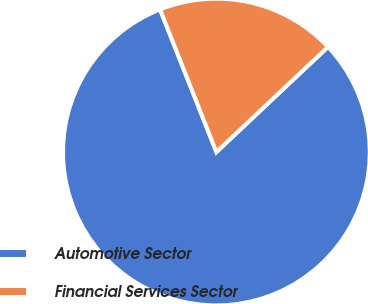Convert chart to OTSL. <chart><loc_0><loc_0><loc_500><loc_500><pie_chart><fcel>Automotive Sector<fcel>Financial Services Sector<nl><fcel>81.04%<fcel>18.96%<nl></chart> 